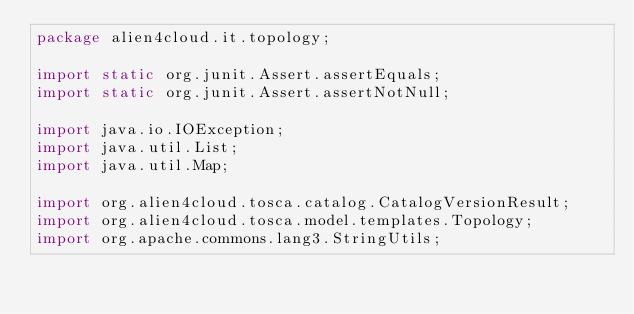<code> <loc_0><loc_0><loc_500><loc_500><_Java_>package alien4cloud.it.topology;

import static org.junit.Assert.assertEquals;
import static org.junit.Assert.assertNotNull;

import java.io.IOException;
import java.util.List;
import java.util.Map;

import org.alien4cloud.tosca.catalog.CatalogVersionResult;
import org.alien4cloud.tosca.model.templates.Topology;
import org.apache.commons.lang3.StringUtils;
</code> 